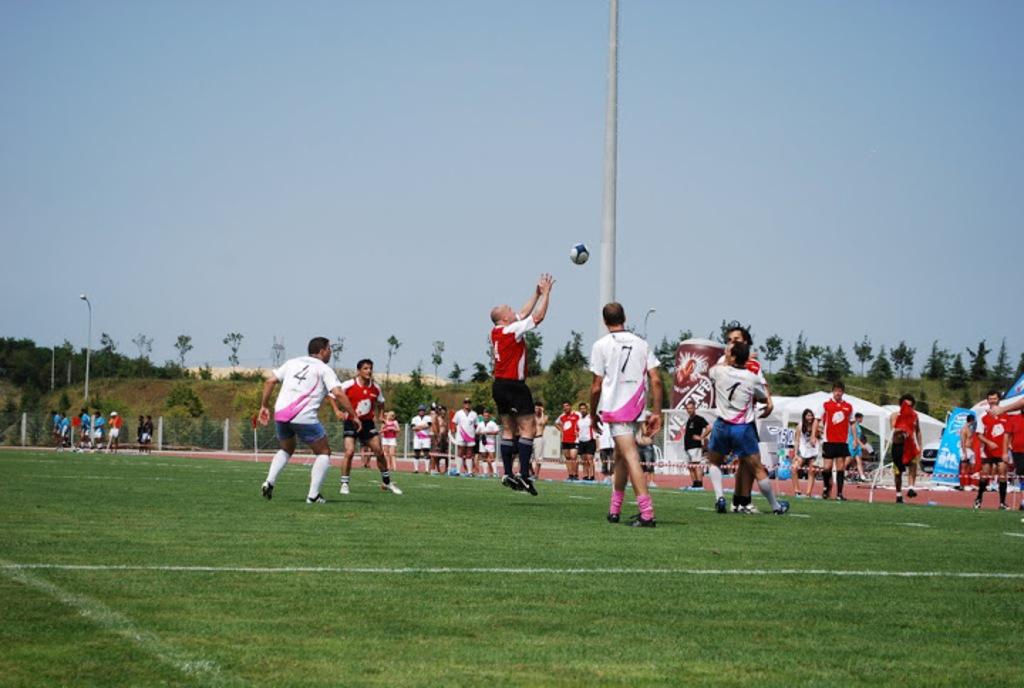What number is the player on the far left?
Your answer should be very brief. 4. 